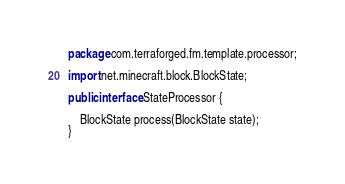Convert code to text. <code><loc_0><loc_0><loc_500><loc_500><_Java_>package com.terraforged.fm.template.processor;

import net.minecraft.block.BlockState;

public interface StateProcessor {

    BlockState process(BlockState state);
}
</code> 